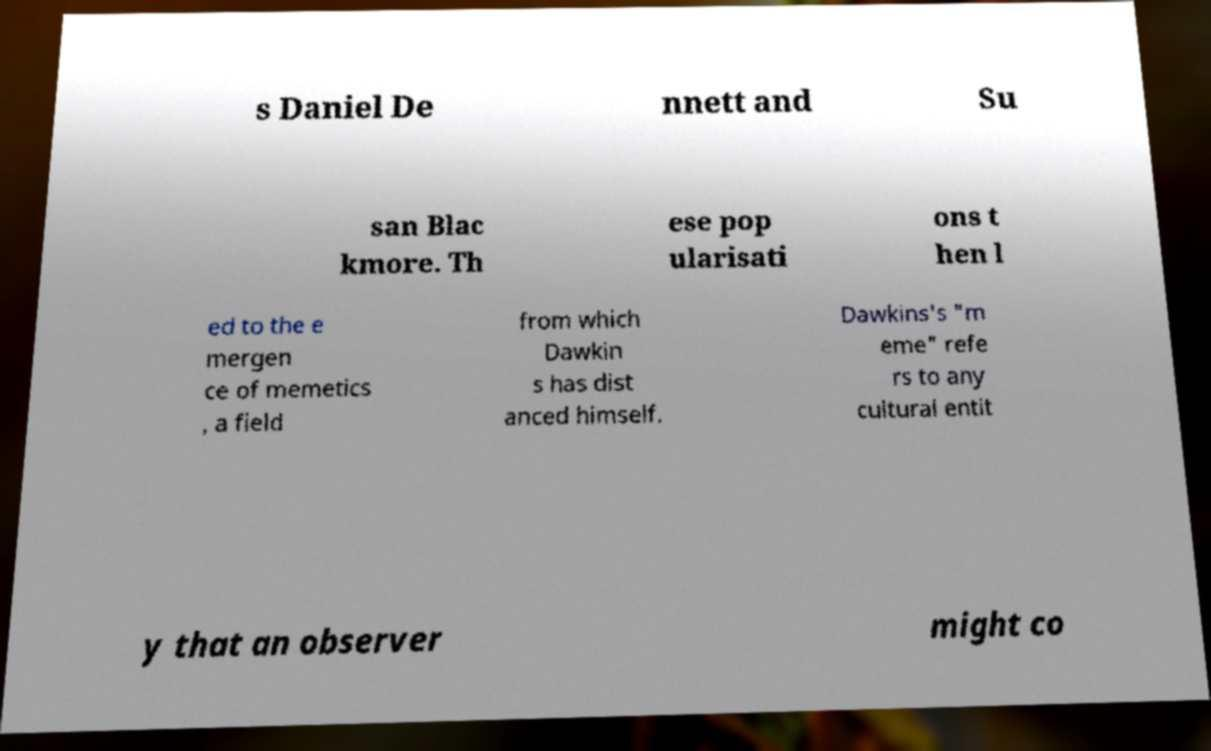For documentation purposes, I need the text within this image transcribed. Could you provide that? s Daniel De nnett and Su san Blac kmore. Th ese pop ularisati ons t hen l ed to the e mergen ce of memetics , a field from which Dawkin s has dist anced himself. Dawkins's "m eme" refe rs to any cultural entit y that an observer might co 